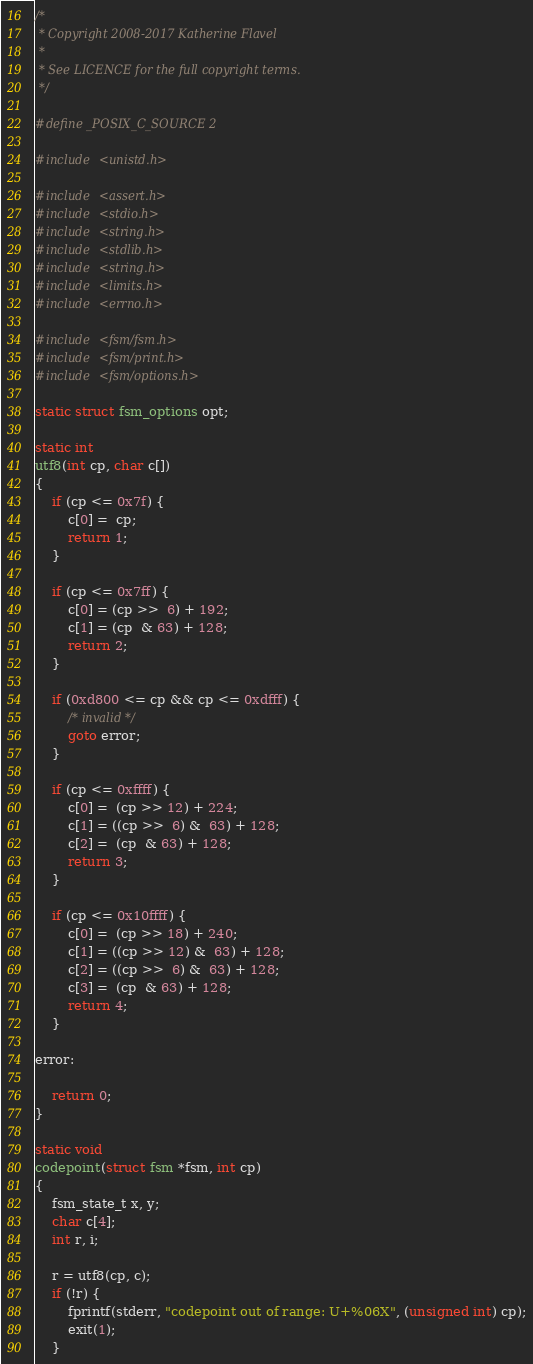<code> <loc_0><loc_0><loc_500><loc_500><_C_>/*
 * Copyright 2008-2017 Katherine Flavel
 *
 * See LICENCE for the full copyright terms.
 */

#define _POSIX_C_SOURCE 2

#include <unistd.h>

#include <assert.h>
#include <stdio.h>
#include <string.h>
#include <stdlib.h>
#include <string.h>
#include <limits.h>
#include <errno.h>

#include <fsm/fsm.h>
#include <fsm/print.h>
#include <fsm/options.h>

static struct fsm_options opt;

static int
utf8(int cp, char c[])
{
	if (cp <= 0x7f) {
		c[0] =  cp;
		return 1;
	}

	if (cp <= 0x7ff) {
		c[0] = (cp >>  6) + 192;
		c[1] = (cp  & 63) + 128;
		return 2;
	}

	if (0xd800 <= cp && cp <= 0xdfff) {
		/* invalid */
		goto error;
	}

	if (cp <= 0xffff) {
		c[0] =  (cp >> 12) + 224;
		c[1] = ((cp >>  6) &  63) + 128;
		c[2] =  (cp  & 63) + 128;
		return 3;
	}

	if (cp <= 0x10ffff) {
		c[0] =  (cp >> 18) + 240;
		c[1] = ((cp >> 12) &  63) + 128;
		c[2] = ((cp >>  6) &  63) + 128;
		c[3] =  (cp  & 63) + 128;
		return 4;
	}

error:

	return 0;
}

static void
codepoint(struct fsm *fsm, int cp)
{
	fsm_state_t x, y;
	char c[4];
	int r, i;

	r = utf8(cp, c);
	if (!r) {
		fprintf(stderr, "codepoint out of range: U+%06X", (unsigned int) cp);
		exit(1);
	}
</code> 